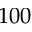<formula> <loc_0><loc_0><loc_500><loc_500>1 0 0</formula> 